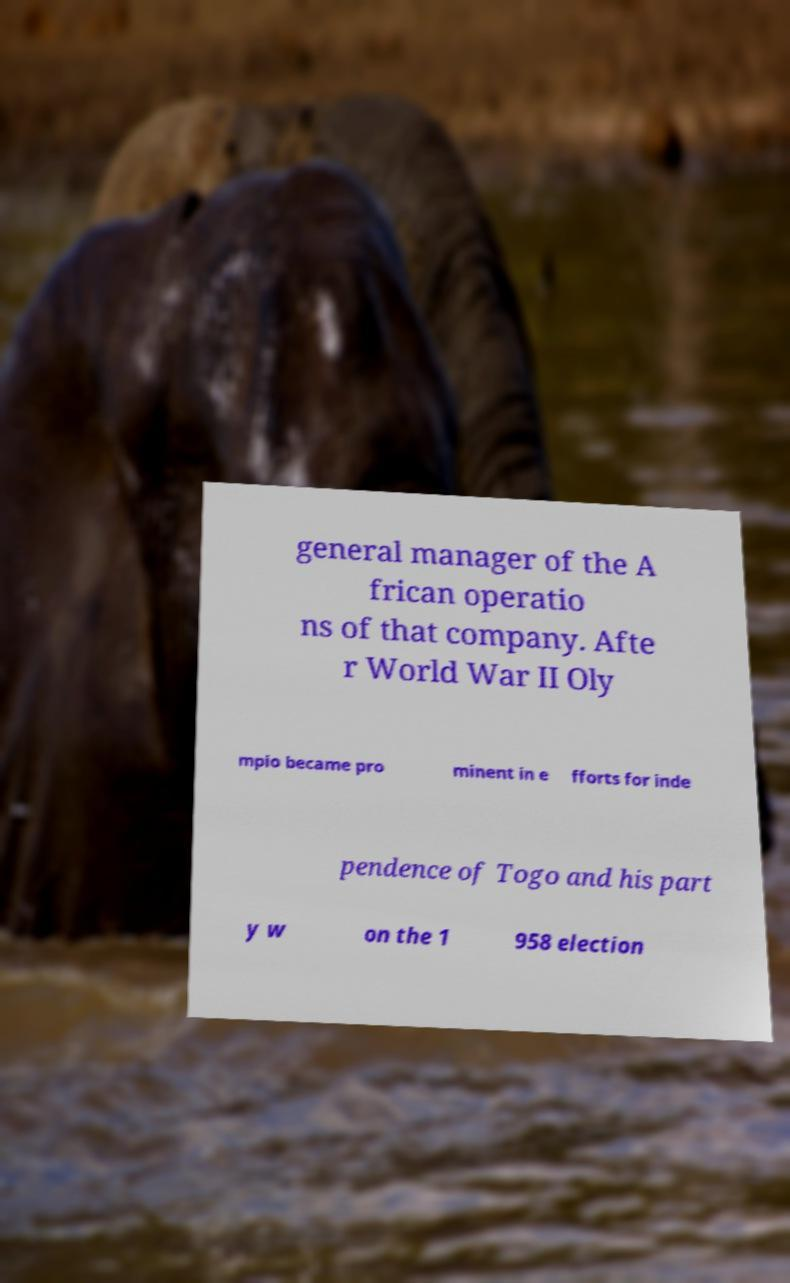Can you read and provide the text displayed in the image?This photo seems to have some interesting text. Can you extract and type it out for me? general manager of the A frican operatio ns of that company. Afte r World War II Oly mpio became pro minent in e fforts for inde pendence of Togo and his part y w on the 1 958 election 